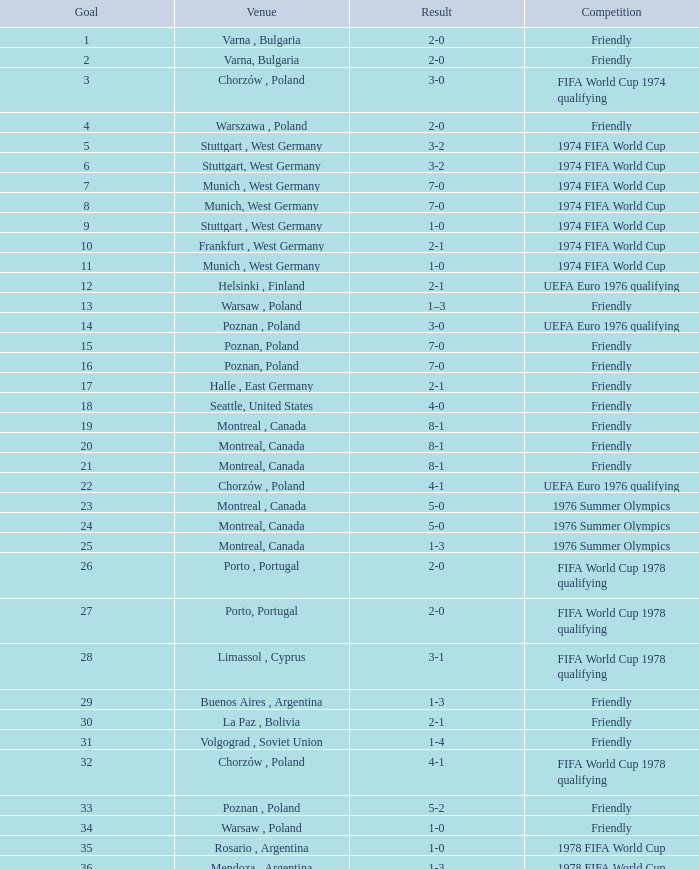What was the result of the game in Stuttgart, West Germany and a goal number of less than 9? 3-2, 3-2. 